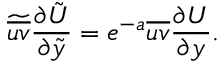Convert formula to latex. <formula><loc_0><loc_0><loc_500><loc_500>\widetilde { \overline { u v } } \frac { \partial \tilde { U } } { \partial \tilde { y } } = e ^ { - a } \overline { u v } \frac { \partial { U } } { \partial { y } } .</formula> 